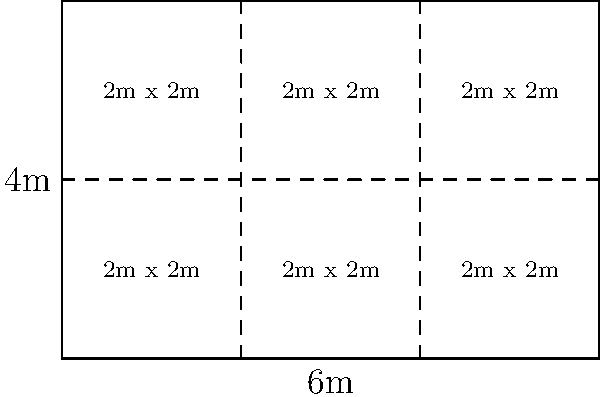A rectangular piece of fabric measures 6 meters by 4 meters. You need to cut it into square pieces with the largest possible size while minimizing waste. What is the optimal side length of each square piece, and how many such pieces can be cut from the fabric? To solve this problem, we need to follow these steps:

1. Identify the factors of both dimensions:
   Factors of 6: 1, 2, 3, 6
   Factors of 4: 1, 2, 4

2. Find the greatest common factor (GCF) of 6 and 4:
   GCF(6, 4) = 2

3. The optimal side length of each square piece is the GCF, which is 2 meters.

4. Calculate the number of pieces that can be cut:
   - Number of pieces along the length: 6 ÷ 2 = 3
   - Number of pieces along the width: 4 ÷ 2 = 2
   - Total number of pieces: 3 × 2 = 6

5. Check for waste:
   - Total area of the fabric: 6 × 4 = 24 sq meters
   - Area of each square piece: 2 × 2 = 4 sq meters
   - Total area of cut pieces: 6 × 4 = 24 sq meters

There is no waste in this cutting pattern, as the entire fabric is used.

Therefore, the optimal cutting pattern is to create squares with a side length of 2 meters, which will yield 6 pieces with no waste.
Answer: 2 meters; 6 pieces 